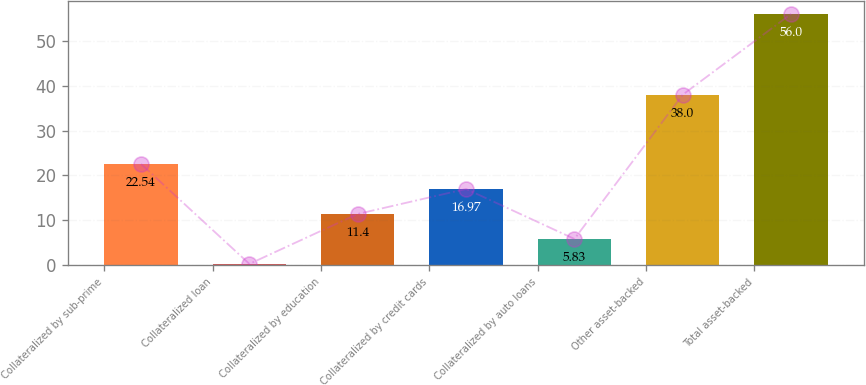<chart> <loc_0><loc_0><loc_500><loc_500><bar_chart><fcel>Collateralized by sub-prime<fcel>Collateralized loan<fcel>Collateralized by education<fcel>Collateralized by credit cards<fcel>Collateralized by auto loans<fcel>Other asset-backed<fcel>Total asset-backed<nl><fcel>22.54<fcel>0.26<fcel>11.4<fcel>16.97<fcel>5.83<fcel>38<fcel>56<nl></chart> 